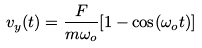<formula> <loc_0><loc_0><loc_500><loc_500>v _ { y } ( t ) = \frac { F } { m \omega _ { o } } [ 1 - \cos ( \omega _ { o } t ) ]</formula> 